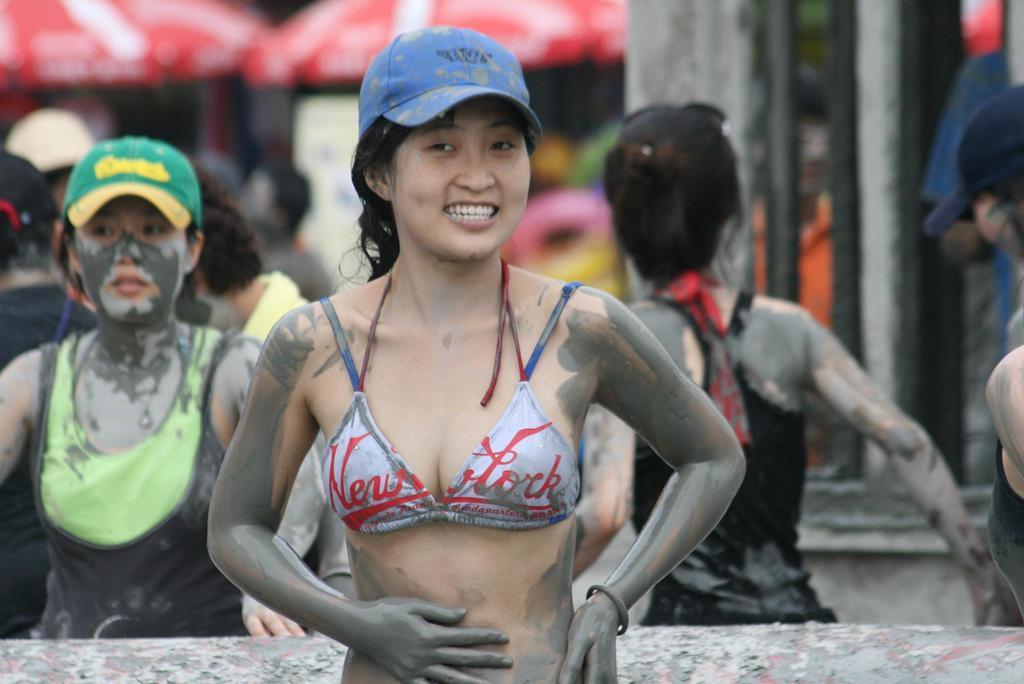In one or two sentences, can you explain what this image depicts? In this image I can see group of people standing, in front the person is wearing gray color dress. Background I can see few umbrellas in red and white color and few poles in gray and black color. 